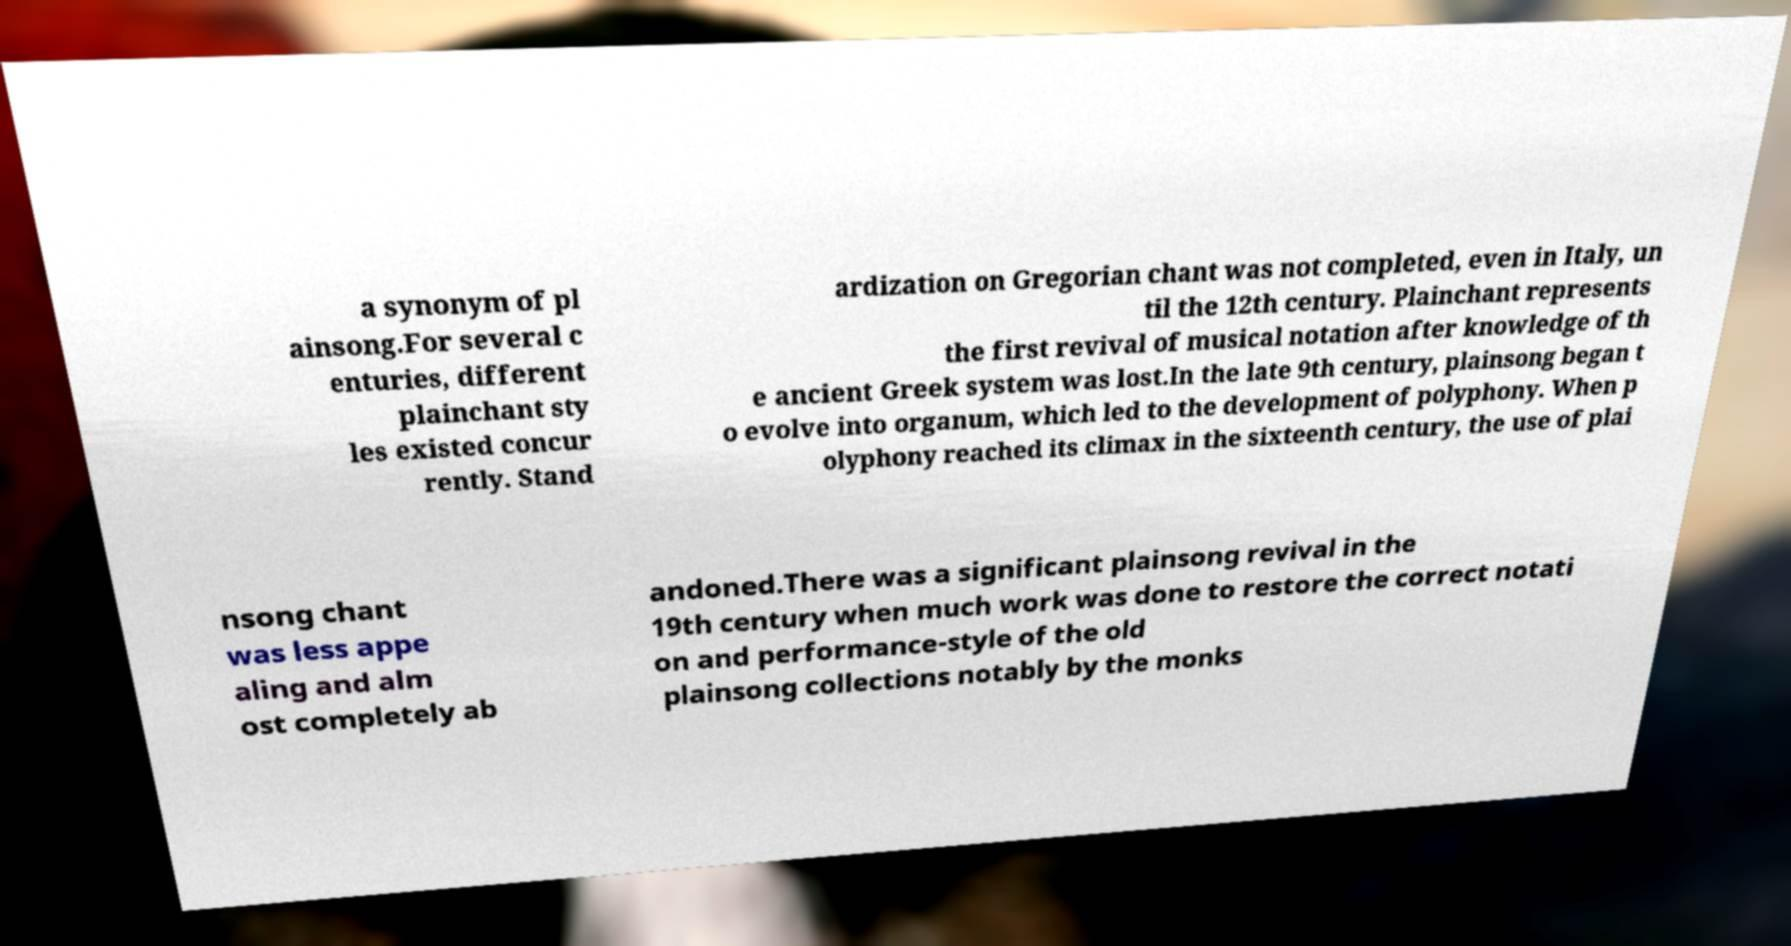Please identify and transcribe the text found in this image. a synonym of pl ainsong.For several c enturies, different plainchant sty les existed concur rently. Stand ardization on Gregorian chant was not completed, even in Italy, un til the 12th century. Plainchant represents the first revival of musical notation after knowledge of th e ancient Greek system was lost.In the late 9th century, plainsong began t o evolve into organum, which led to the development of polyphony. When p olyphony reached its climax in the sixteenth century, the use of plai nsong chant was less appe aling and alm ost completely ab andoned.There was a significant plainsong revival in the 19th century when much work was done to restore the correct notati on and performance-style of the old plainsong collections notably by the monks 